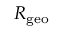Convert formula to latex. <formula><loc_0><loc_0><loc_500><loc_500>R _ { g e o }</formula> 